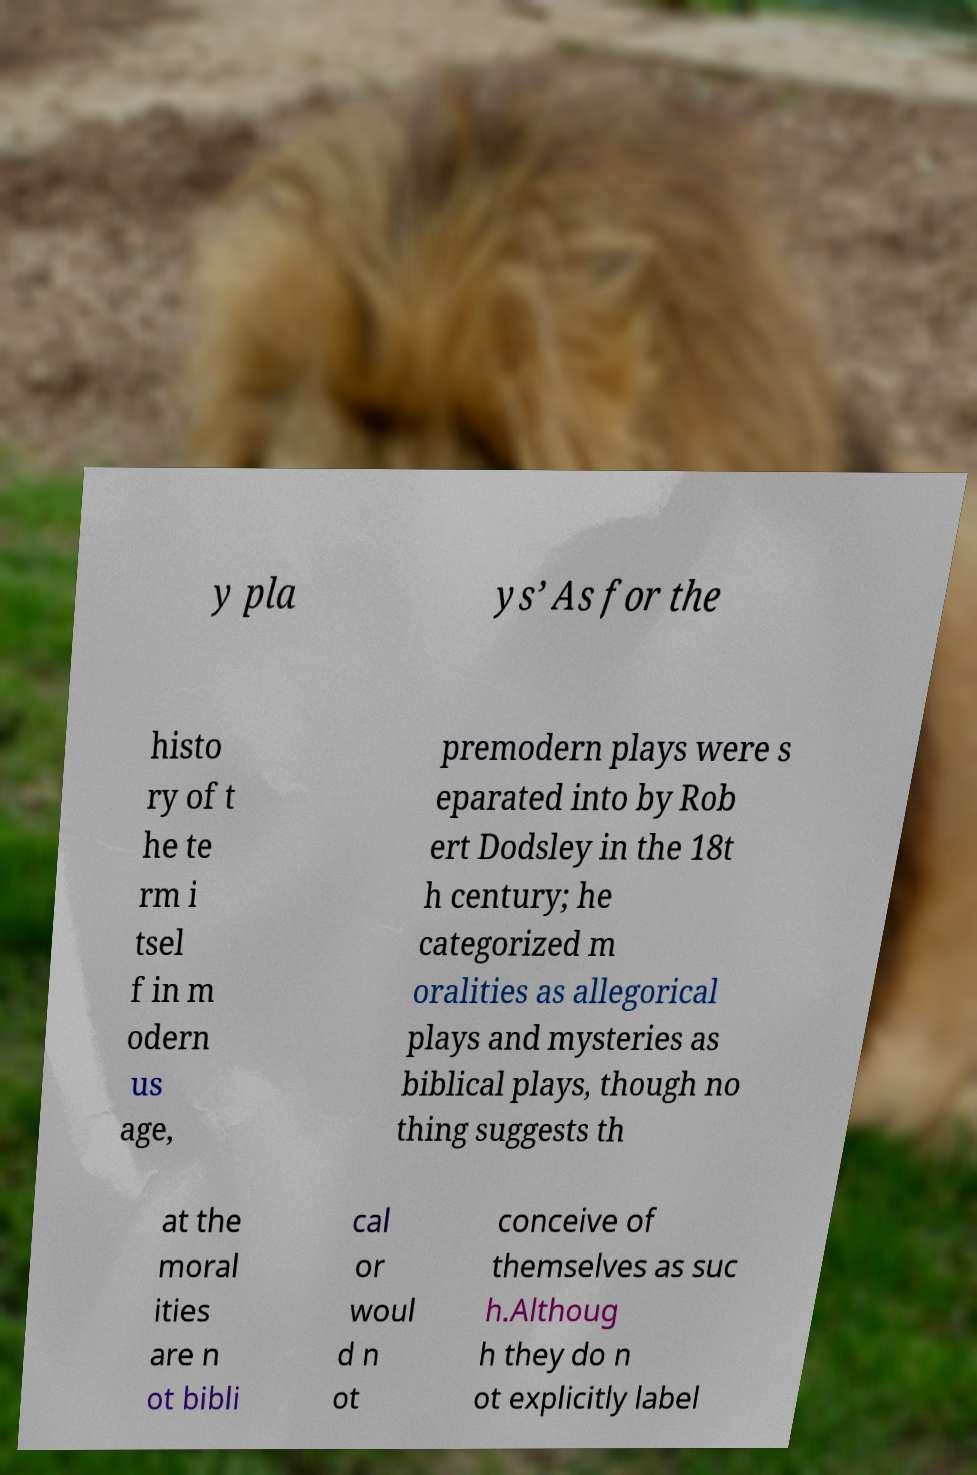Please identify and transcribe the text found in this image. y pla ys’ As for the histo ry of t he te rm i tsel f in m odern us age, premodern plays were s eparated into by Rob ert Dodsley in the 18t h century; he categorized m oralities as allegorical plays and mysteries as biblical plays, though no thing suggests th at the moral ities are n ot bibli cal or woul d n ot conceive of themselves as suc h.Althoug h they do n ot explicitly label 